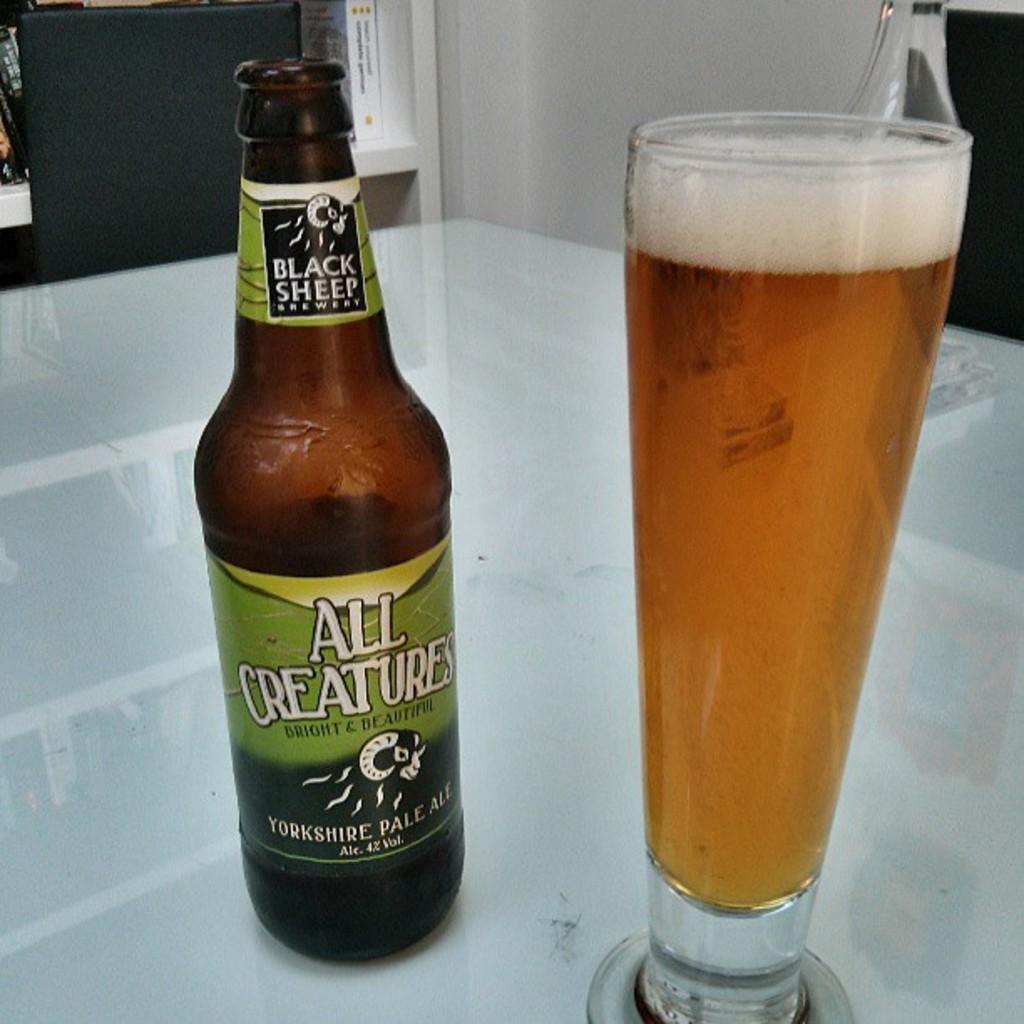What is the name of the brewery that manufactures this ale?
Offer a terse response. Black sheep. What is the name of this beer?
Offer a very short reply. All creatures. 